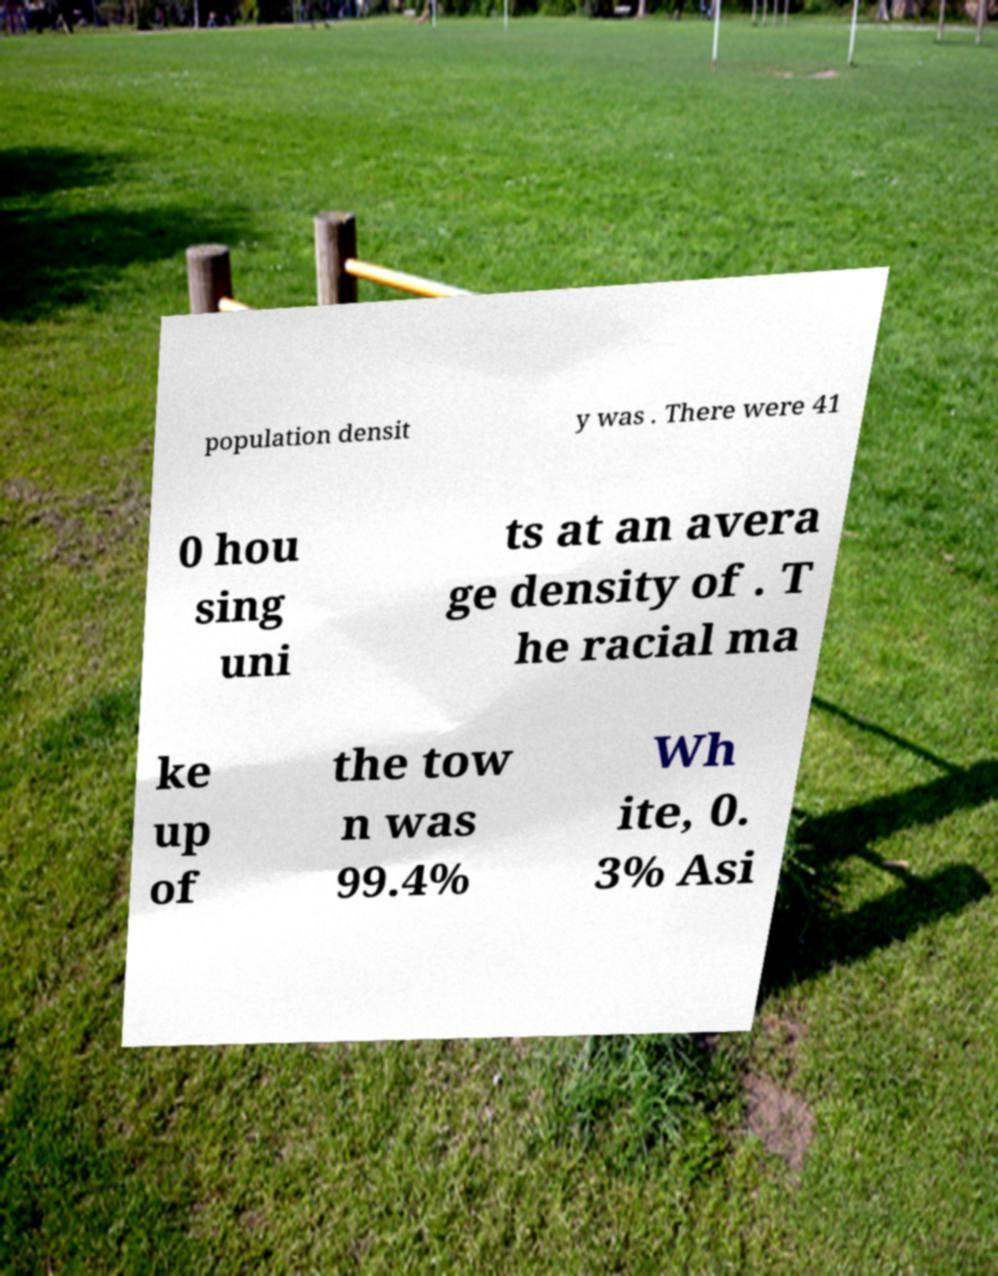Please read and relay the text visible in this image. What does it say? population densit y was . There were 41 0 hou sing uni ts at an avera ge density of . T he racial ma ke up of the tow n was 99.4% Wh ite, 0. 3% Asi 